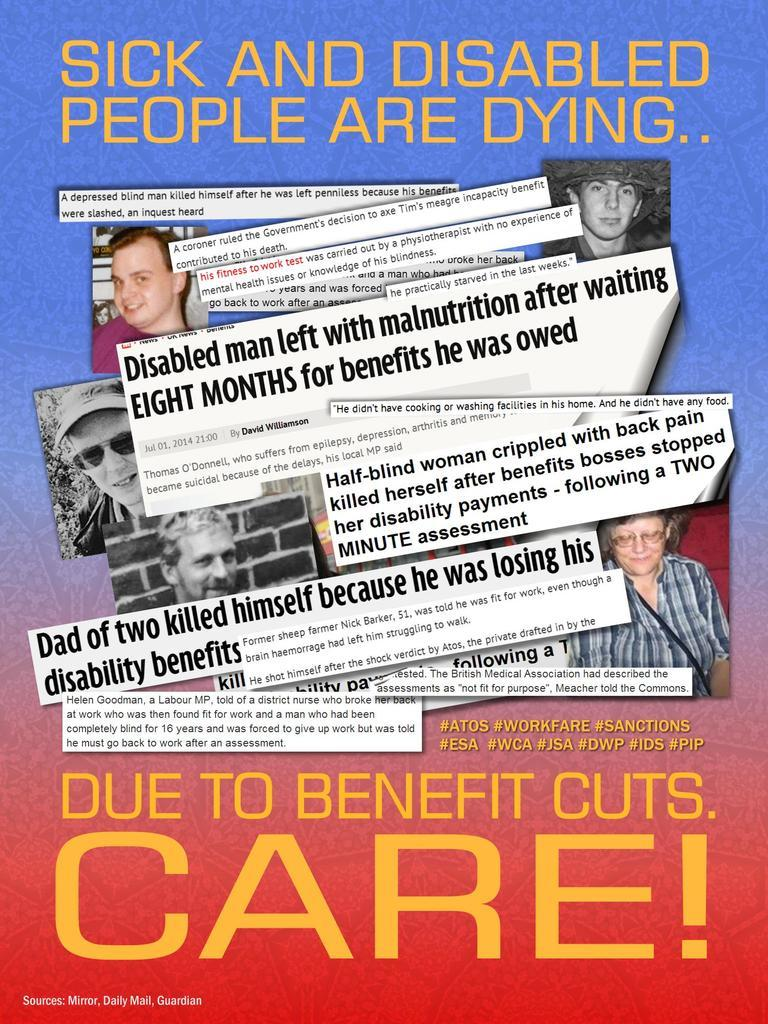<image>
Write a terse but informative summary of the picture. A political poster which claims that sick and disabled people are dying. 